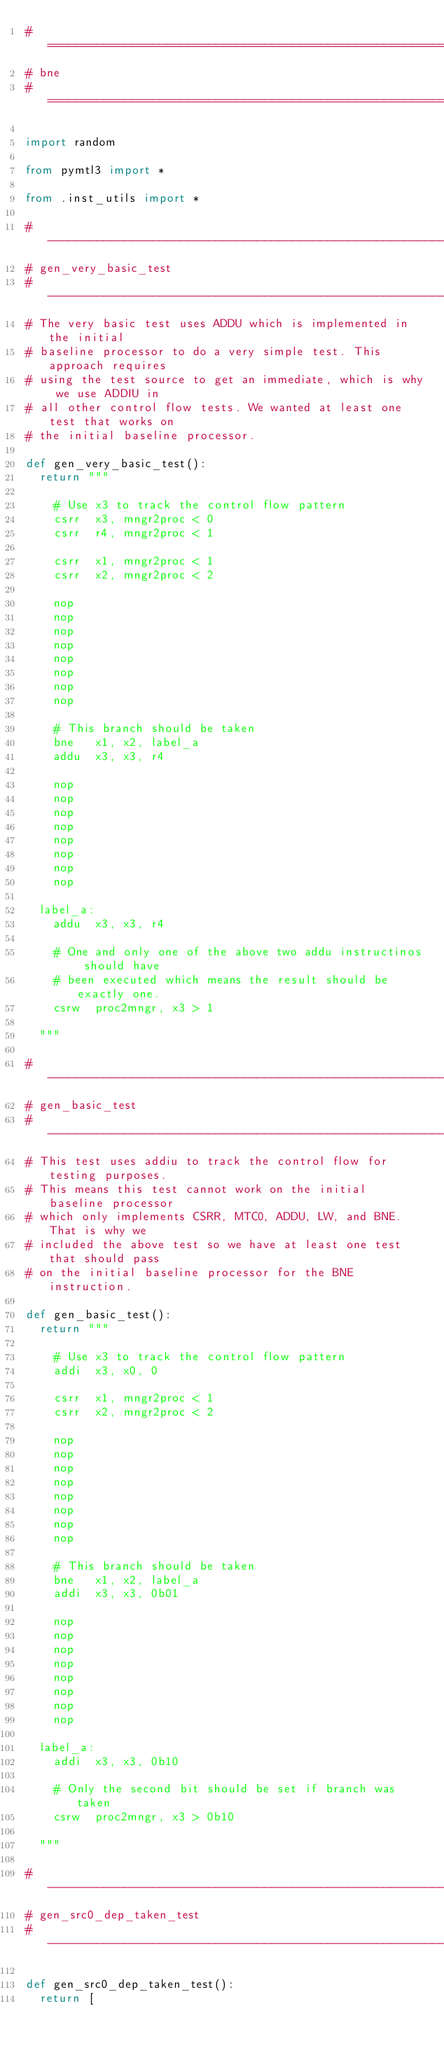<code> <loc_0><loc_0><loc_500><loc_500><_Python_>#=========================================================================
# bne
#=========================================================================

import random

from pymtl3 import *

from .inst_utils import *

#-------------------------------------------------------------------------
# gen_very_basic_test
#-------------------------------------------------------------------------
# The very basic test uses ADDU which is implemented in the initial
# baseline processor to do a very simple test. This approach requires
# using the test source to get an immediate, which is why we use ADDIU in
# all other control flow tests. We wanted at least one test that works on
# the initial baseline processor.

def gen_very_basic_test():
  return """

    # Use x3 to track the control flow pattern
    csrr  x3, mngr2proc < 0
    csrr  r4, mngr2proc < 1

    csrr  x1, mngr2proc < 1
    csrr  x2, mngr2proc < 2

    nop
    nop
    nop
    nop
    nop
    nop
    nop
    nop

    # This branch should be taken
    bne   x1, x2, label_a
    addu  x3, x3, r4

    nop
    nop
    nop
    nop
    nop
    nop
    nop
    nop

  label_a:
    addu  x3, x3, r4

    # One and only one of the above two addu instructinos should have
    # been executed which means the result should be exactly one.
    csrw  proc2mngr, x3 > 1

  """

#-------------------------------------------------------------------------
# gen_basic_test
#-------------------------------------------------------------------------
# This test uses addiu to track the control flow for testing purposes.
# This means this test cannot work on the initial baseline processor
# which only implements CSRR, MTC0, ADDU, LW, and BNE. That is why we
# included the above test so we have at least one test that should pass
# on the initial baseline processor for the BNE instruction.

def gen_basic_test():
  return """

    # Use x3 to track the control flow pattern
    addi  x3, x0, 0

    csrr  x1, mngr2proc < 1
    csrr  x2, mngr2proc < 2

    nop
    nop
    nop
    nop
    nop
    nop
    nop
    nop

    # This branch should be taken
    bne   x1, x2, label_a
    addi  x3, x3, 0b01

    nop
    nop
    nop
    nop
    nop
    nop
    nop
    nop

  label_a:
    addi  x3, x3, 0b10

    # Only the second bit should be set if branch was taken
    csrw  proc2mngr, x3 > 0b10

  """

#-------------------------------------------------------------------------
# gen_src0_dep_taken_test
#-------------------------------------------------------------------------

def gen_src0_dep_taken_test():
  return [</code> 